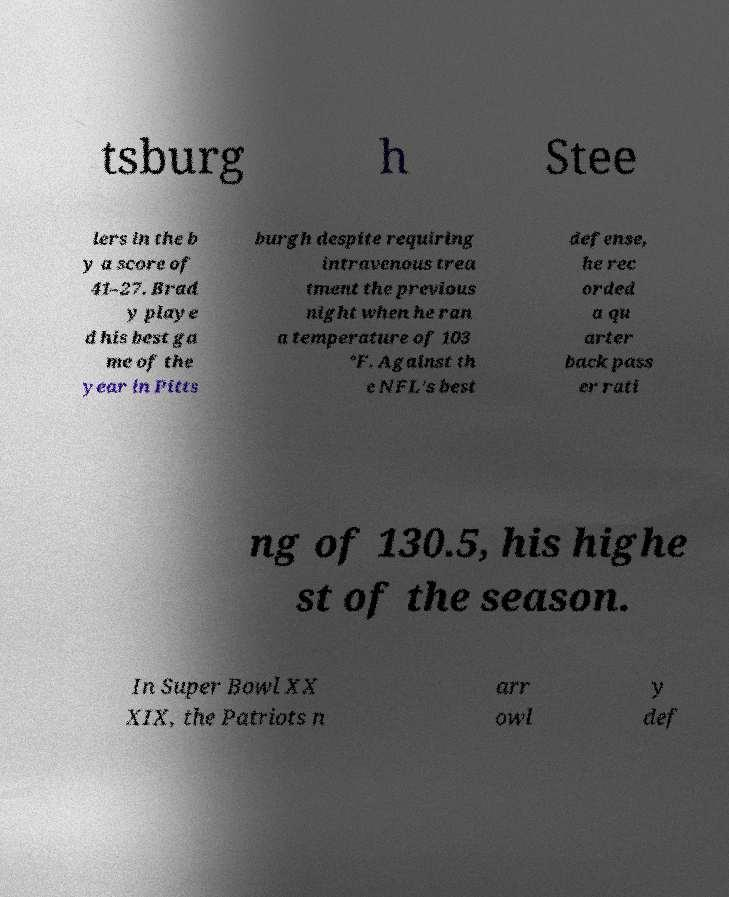Could you extract and type out the text from this image? tsburg h Stee lers in the b y a score of 41–27. Brad y playe d his best ga me of the year in Pitts burgh despite requiring intravenous trea tment the previous night when he ran a temperature of 103 °F. Against th e NFL's best defense, he rec orded a qu arter back pass er rati ng of 130.5, his highe st of the season. In Super Bowl XX XIX, the Patriots n arr owl y def 